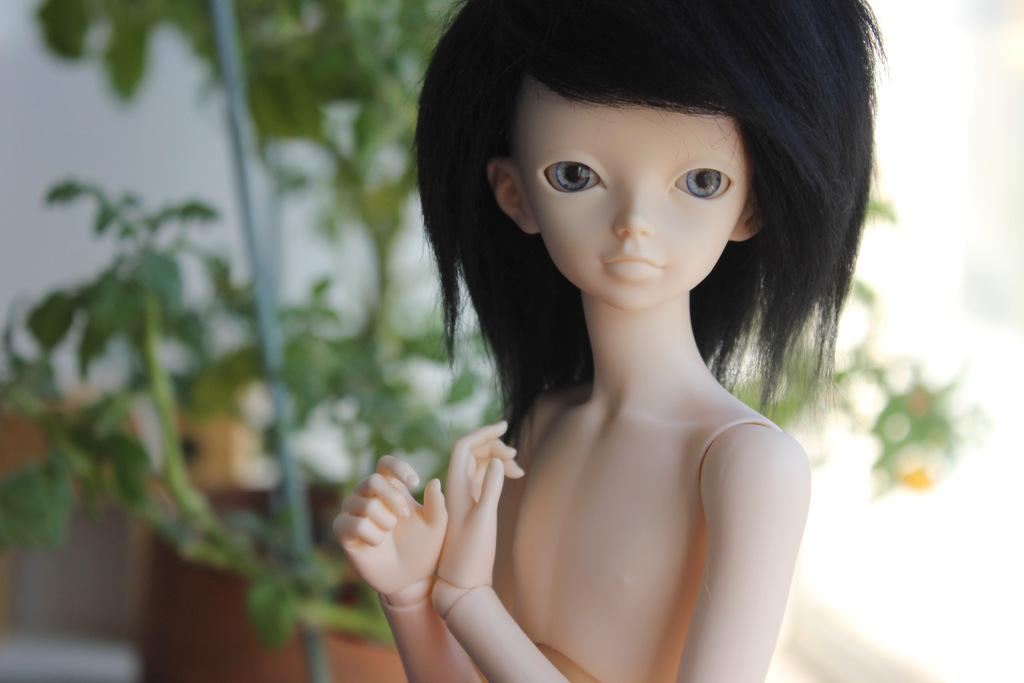What is the main subject in the image? There is a doll in the image. What can be seen in the background of the image? There are plants and a wall in the background of the image. Is there a girl holding an umbrella in the image? There is no girl or umbrella present in the image. Is it raining in the image? There is no indication of rain in the image. 